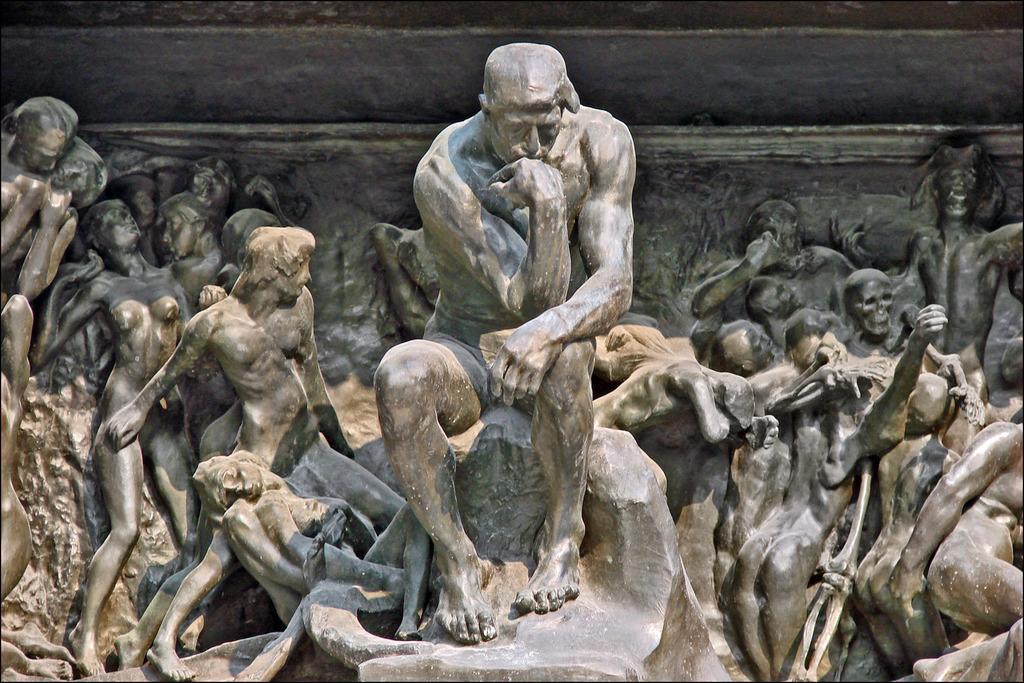Describe this image in one or two sentences. In the picture we can see the people sculptures and behind it we can see a part of the wall. 